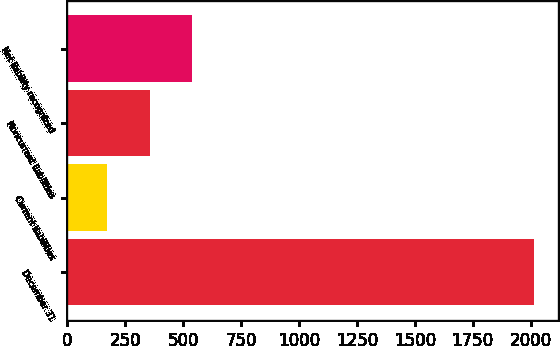Convert chart to OTSL. <chart><loc_0><loc_0><loc_500><loc_500><bar_chart><fcel>December 31<fcel>Current liabilities<fcel>Noncurrent liabilities<fcel>Net liability recognized<nl><fcel>2016<fcel>171<fcel>355.5<fcel>540<nl></chart> 